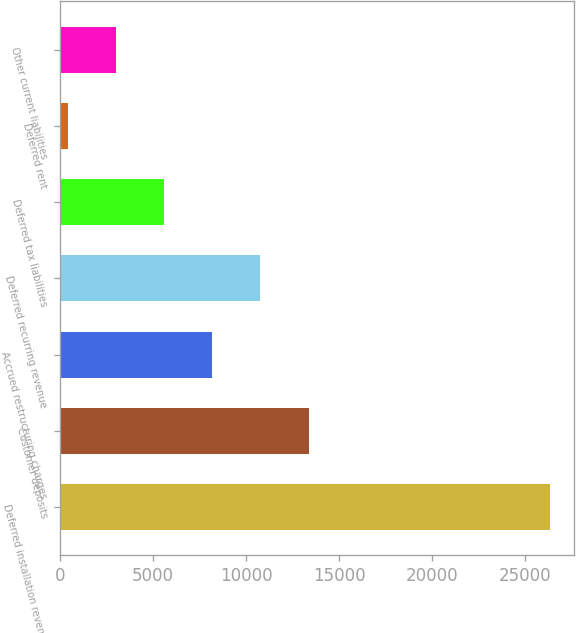Convert chart. <chart><loc_0><loc_0><loc_500><loc_500><bar_chart><fcel>Deferred installation revenue<fcel>Customer deposits<fcel>Accrued restructuring charges<fcel>Deferred recurring revenue<fcel>Deferred tax liabilities<fcel>Deferred rent<fcel>Other current liabilities<nl><fcel>26319<fcel>13361<fcel>8177.8<fcel>10769.4<fcel>5586.2<fcel>403<fcel>2994.6<nl></chart> 